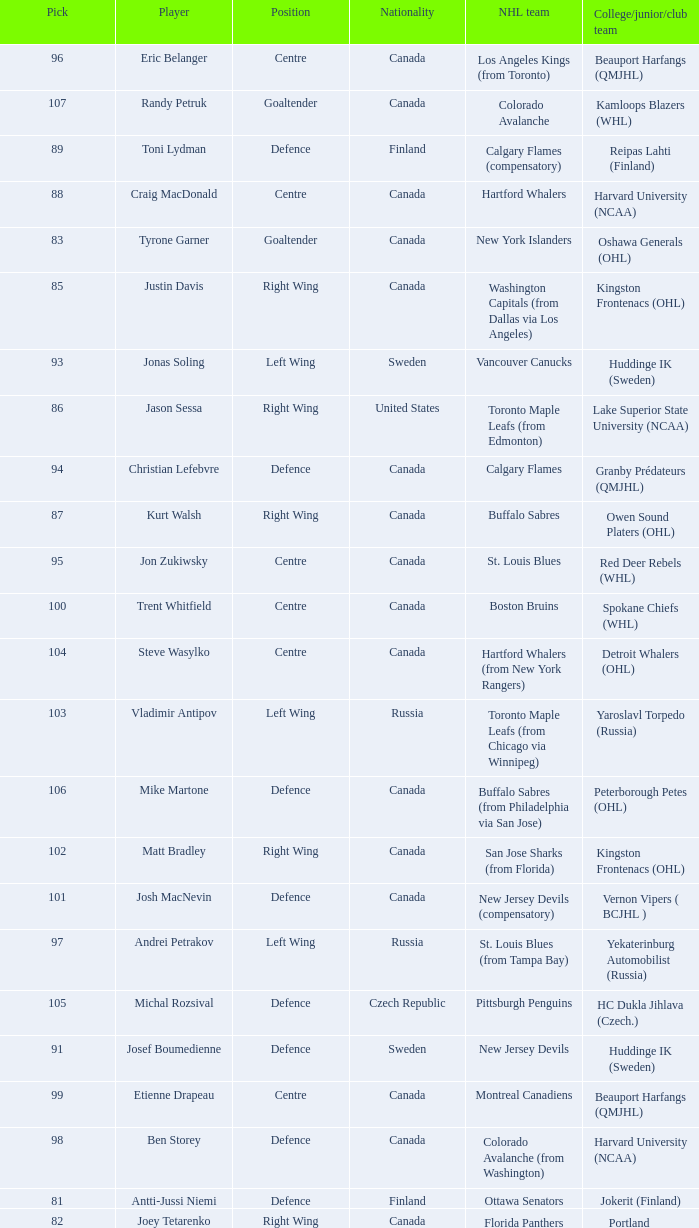What is the nationality of Christian Lefebvre? Canada. 